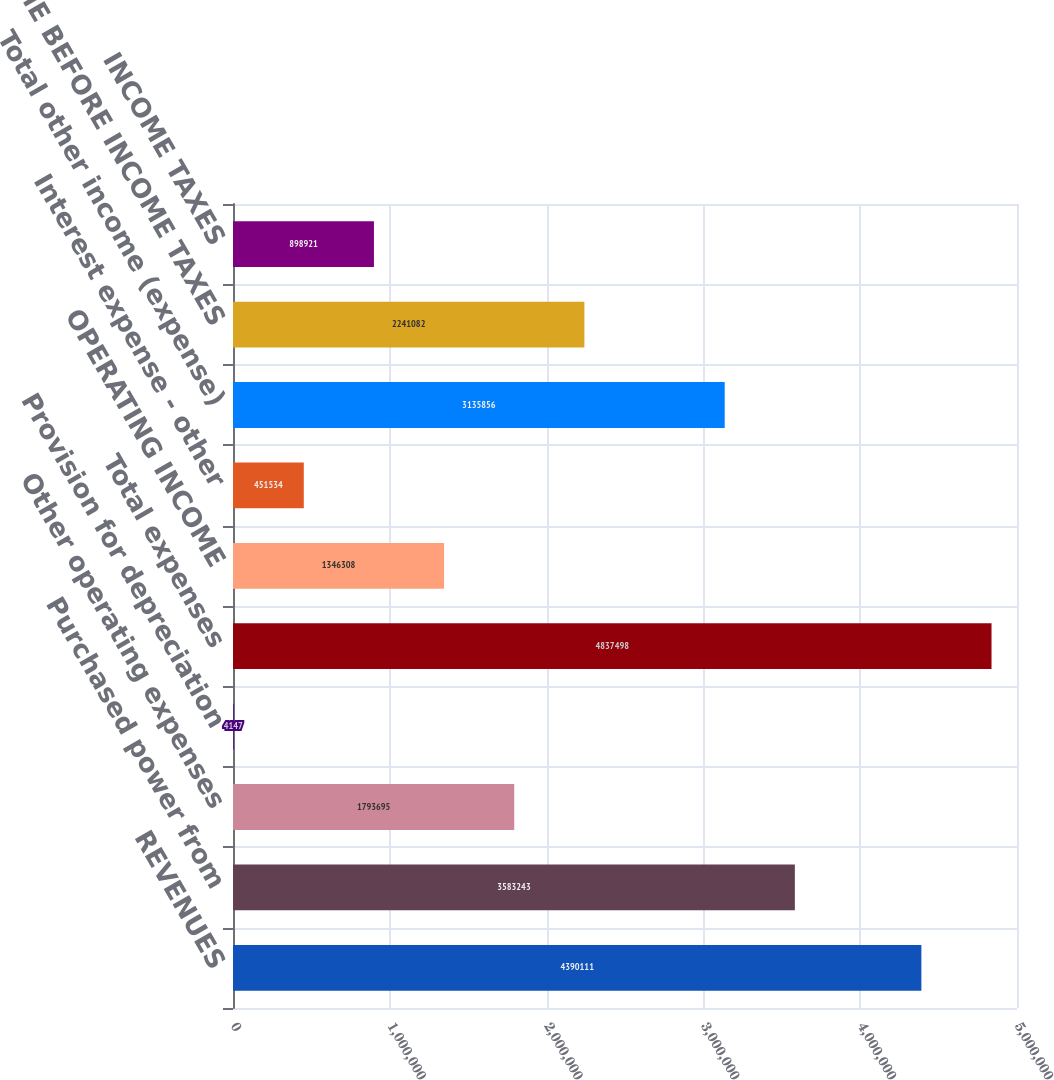<chart> <loc_0><loc_0><loc_500><loc_500><bar_chart><fcel>REVENUES<fcel>Purchased power from<fcel>Other operating expenses<fcel>Provision for depreciation<fcel>Total expenses<fcel>OPERATING INCOME<fcel>Interest expense - other<fcel>Total other income (expense)<fcel>INCOME BEFORE INCOME TAXES<fcel>INCOME TAXES<nl><fcel>4.39011e+06<fcel>3.58324e+06<fcel>1.7937e+06<fcel>4147<fcel>4.8375e+06<fcel>1.34631e+06<fcel>451534<fcel>3.13586e+06<fcel>2.24108e+06<fcel>898921<nl></chart> 